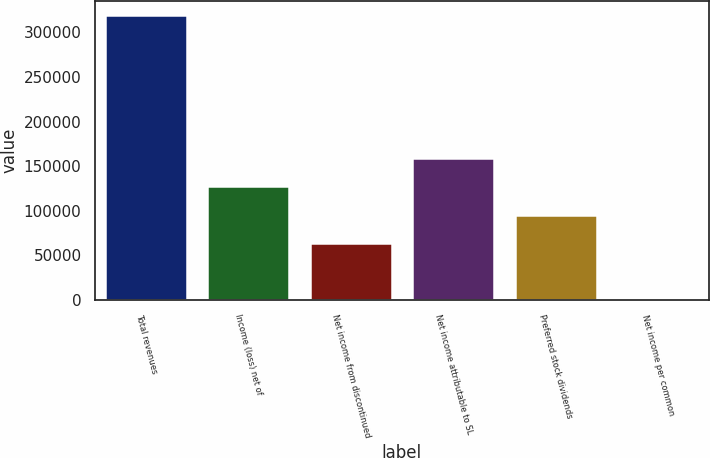Convert chart to OTSL. <chart><loc_0><loc_0><loc_500><loc_500><bar_chart><fcel>Total revenues<fcel>Income (loss) net of<fcel>Net income from discontinued<fcel>Net income attributable to SL<fcel>Preferred stock dividends<fcel>Net income per common<nl><fcel>319149<fcel>127660<fcel>63830.9<fcel>159575<fcel>95745.7<fcel>1.42<nl></chart> 